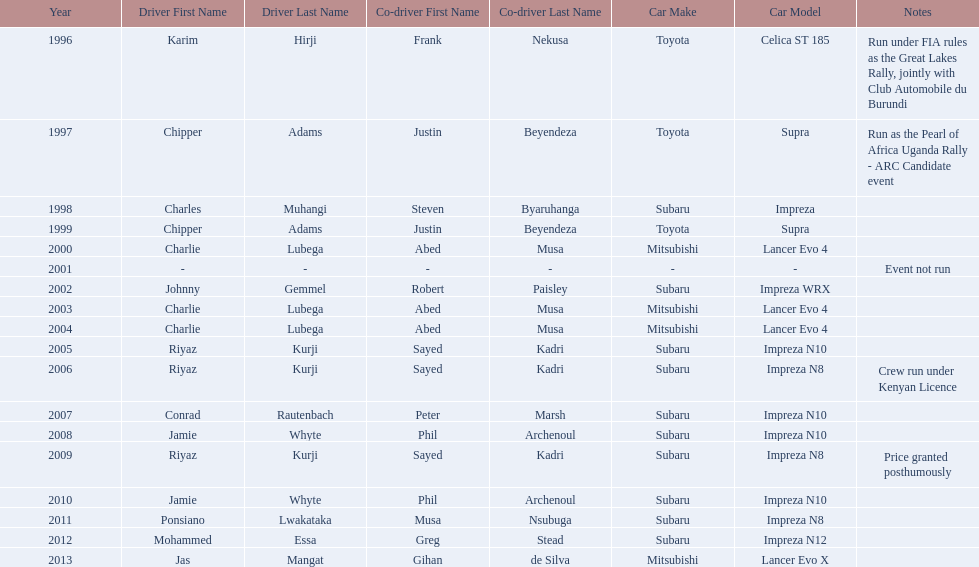Do chipper adams and justin beyendeza have more than 3 wins? No. 